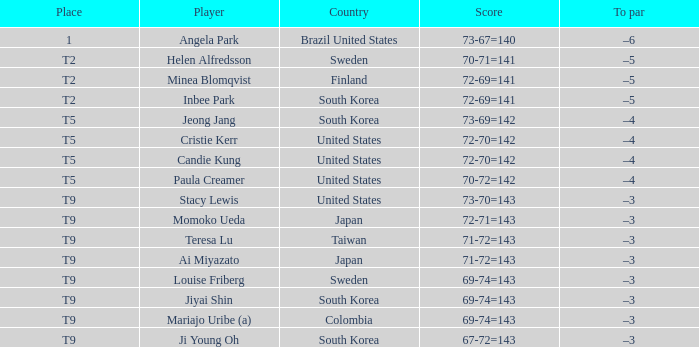Parse the table in full. {'header': ['Place', 'Player', 'Country', 'Score', 'To par'], 'rows': [['1', 'Angela Park', 'Brazil United States', '73-67=140', '–6'], ['T2', 'Helen Alfredsson', 'Sweden', '70-71=141', '–5'], ['T2', 'Minea Blomqvist', 'Finland', '72-69=141', '–5'], ['T2', 'Inbee Park', 'South Korea', '72-69=141', '–5'], ['T5', 'Jeong Jang', 'South Korea', '73-69=142', '–4'], ['T5', 'Cristie Kerr', 'United States', '72-70=142', '–4'], ['T5', 'Candie Kung', 'United States', '72-70=142', '–4'], ['T5', 'Paula Creamer', 'United States', '70-72=142', '–4'], ['T9', 'Stacy Lewis', 'United States', '73-70=143', '–3'], ['T9', 'Momoko Ueda', 'Japan', '72-71=143', '–3'], ['T9', 'Teresa Lu', 'Taiwan', '71-72=143', '–3'], ['T9', 'Ai Miyazato', 'Japan', '71-72=143', '–3'], ['T9', 'Louise Friberg', 'Sweden', '69-74=143', '–3'], ['T9', 'Jiyai Shin', 'South Korea', '69-74=143', '–3'], ['T9', 'Mariajo Uribe (a)', 'Colombia', '69-74=143', '–3'], ['T9', 'Ji Young Oh', 'South Korea', '67-72=143', '–3']]} What was momoko ueda's position? T9. 